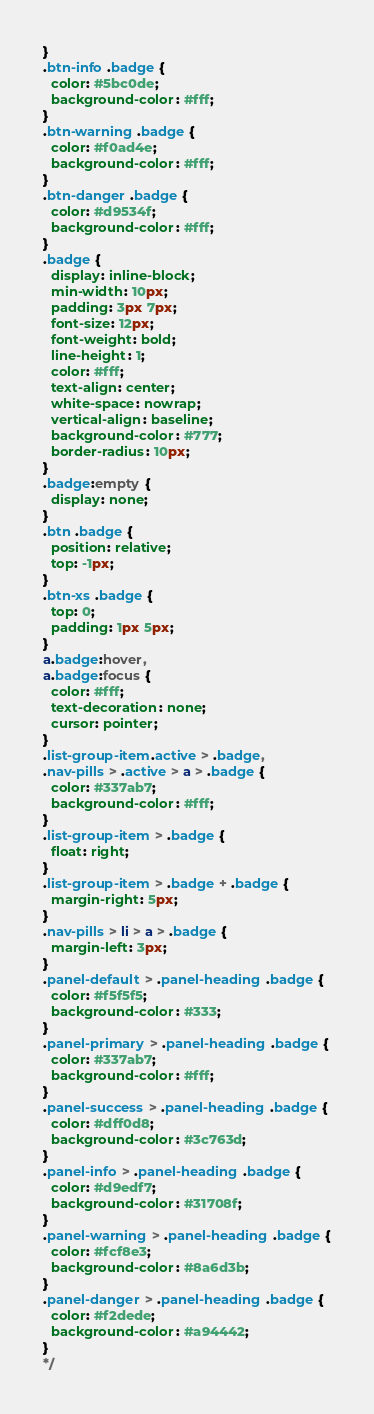Convert code to text. <code><loc_0><loc_0><loc_500><loc_500><_CSS_>}
.btn-info .badge {
  color: #5bc0de;
  background-color: #fff;
}
.btn-warning .badge {
  color: #f0ad4e;
  background-color: #fff;
}
.btn-danger .badge {
  color: #d9534f;
  background-color: #fff;
}
.badge {
  display: inline-block;
  min-width: 10px;
  padding: 3px 7px;
  font-size: 12px;
  font-weight: bold;
  line-height: 1;
  color: #fff;
  text-align: center;
  white-space: nowrap;
  vertical-align: baseline;
  background-color: #777;
  border-radius: 10px;
}
.badge:empty {
  display: none;
}
.btn .badge {
  position: relative;
  top: -1px;
}
.btn-xs .badge {
  top: 0;
  padding: 1px 5px;
}
a.badge:hover,
a.badge:focus {
  color: #fff;
  text-decoration: none;
  cursor: pointer;
}
.list-group-item.active > .badge,
.nav-pills > .active > a > .badge {
  color: #337ab7;
  background-color: #fff;
}
.list-group-item > .badge {
  float: right;
}
.list-group-item > .badge + .badge {
  margin-right: 5px;
}
.nav-pills > li > a > .badge {
  margin-left: 3px;
}
.panel-default > .panel-heading .badge {
  color: #f5f5f5;
  background-color: #333;
}
.panel-primary > .panel-heading .badge {
  color: #337ab7;
  background-color: #fff;
}
.panel-success > .panel-heading .badge {
  color: #dff0d8;
  background-color: #3c763d;
}
.panel-info > .panel-heading .badge {
  color: #d9edf7;
  background-color: #31708f;
}
.panel-warning > .panel-heading .badge {
  color: #fcf8e3;
  background-color: #8a6d3b;
}
.panel-danger > .panel-heading .badge {
  color: #f2dede;
  background-color: #a94442;
}
*/</code> 